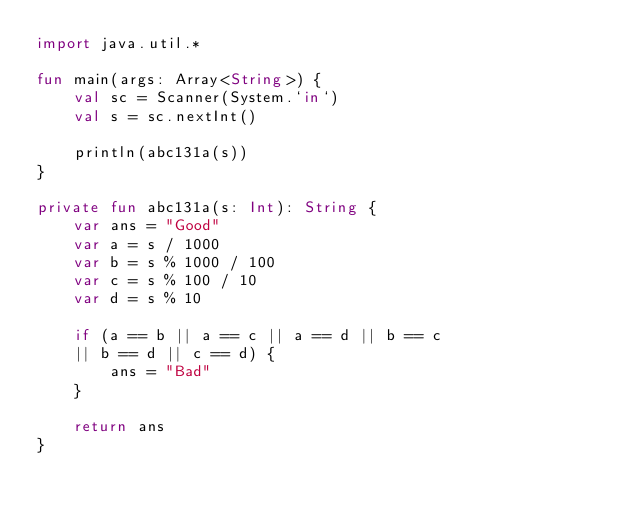<code> <loc_0><loc_0><loc_500><loc_500><_Kotlin_>import java.util.*

fun main(args: Array<String>) {
    val sc = Scanner(System.`in`)
    val s = sc.nextInt()

    println(abc131a(s))
}

private fun abc131a(s: Int): String {
    var ans = "Good"
    var a = s / 1000
    var b = s % 1000 / 100
    var c = s % 100 / 10
    var d = s % 10

    if (a == b || a == c || a == d || b == c
    || b == d || c == d) {
        ans = "Bad"
    }

    return ans
}</code> 